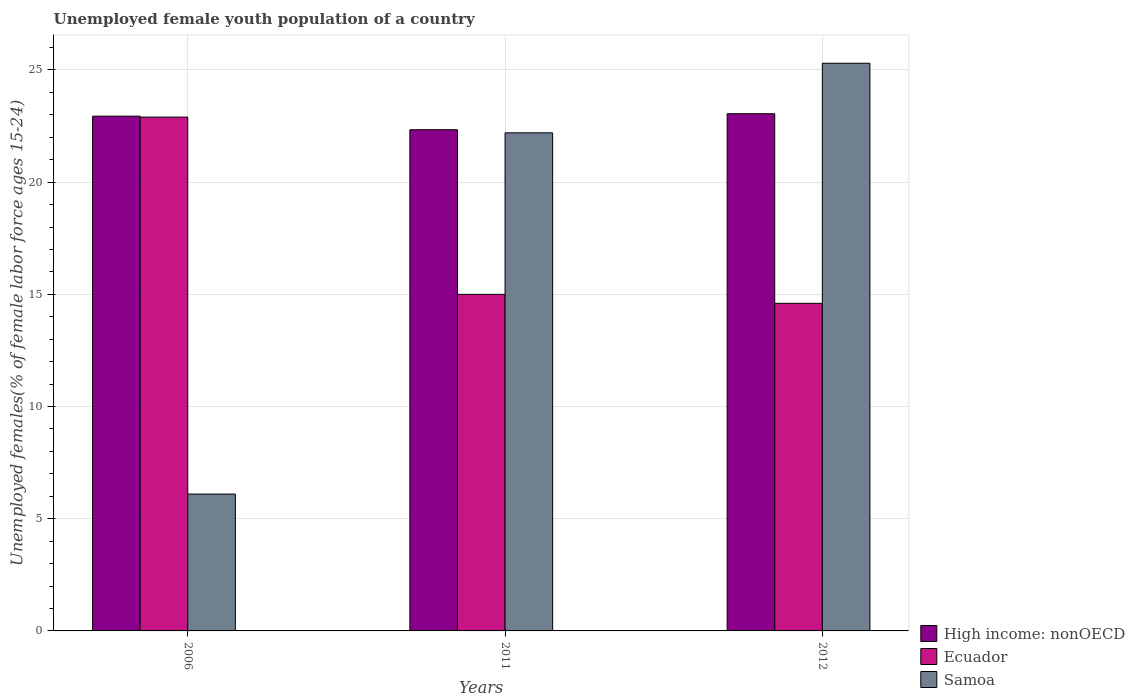How many different coloured bars are there?
Provide a succinct answer. 3. How many bars are there on the 3rd tick from the left?
Make the answer very short. 3. How many bars are there on the 1st tick from the right?
Keep it short and to the point. 3. What is the label of the 1st group of bars from the left?
Your answer should be compact. 2006. What is the percentage of unemployed female youth population in High income: nonOECD in 2006?
Give a very brief answer. 22.94. Across all years, what is the maximum percentage of unemployed female youth population in High income: nonOECD?
Your answer should be very brief. 23.05. Across all years, what is the minimum percentage of unemployed female youth population in High income: nonOECD?
Offer a very short reply. 22.34. In which year was the percentage of unemployed female youth population in High income: nonOECD maximum?
Your answer should be compact. 2012. In which year was the percentage of unemployed female youth population in High income: nonOECD minimum?
Keep it short and to the point. 2011. What is the total percentage of unemployed female youth population in Ecuador in the graph?
Your response must be concise. 52.5. What is the difference between the percentage of unemployed female youth population in High income: nonOECD in 2011 and that in 2012?
Your response must be concise. -0.71. What is the difference between the percentage of unemployed female youth population in Samoa in 2012 and the percentage of unemployed female youth population in Ecuador in 2006?
Give a very brief answer. 2.4. What is the average percentage of unemployed female youth population in Ecuador per year?
Your answer should be compact. 17.5. In the year 2011, what is the difference between the percentage of unemployed female youth population in Samoa and percentage of unemployed female youth population in Ecuador?
Ensure brevity in your answer.  7.2. What is the ratio of the percentage of unemployed female youth population in High income: nonOECD in 2006 to that in 2012?
Give a very brief answer. 1. What is the difference between the highest and the second highest percentage of unemployed female youth population in High income: nonOECD?
Your answer should be compact. 0.11. What is the difference between the highest and the lowest percentage of unemployed female youth population in High income: nonOECD?
Offer a very short reply. 0.71. In how many years, is the percentage of unemployed female youth population in Ecuador greater than the average percentage of unemployed female youth population in Ecuador taken over all years?
Keep it short and to the point. 1. Is the sum of the percentage of unemployed female youth population in High income: nonOECD in 2006 and 2012 greater than the maximum percentage of unemployed female youth population in Samoa across all years?
Provide a short and direct response. Yes. What does the 2nd bar from the left in 2006 represents?
Offer a terse response. Ecuador. What does the 3rd bar from the right in 2006 represents?
Keep it short and to the point. High income: nonOECD. Is it the case that in every year, the sum of the percentage of unemployed female youth population in Ecuador and percentage of unemployed female youth population in High income: nonOECD is greater than the percentage of unemployed female youth population in Samoa?
Your answer should be compact. Yes. Are all the bars in the graph horizontal?
Your answer should be very brief. No. How many years are there in the graph?
Your answer should be compact. 3. Are the values on the major ticks of Y-axis written in scientific E-notation?
Provide a succinct answer. No. Does the graph contain grids?
Your response must be concise. Yes. How many legend labels are there?
Offer a very short reply. 3. How are the legend labels stacked?
Keep it short and to the point. Vertical. What is the title of the graph?
Offer a very short reply. Unemployed female youth population of a country. What is the label or title of the X-axis?
Your answer should be compact. Years. What is the label or title of the Y-axis?
Give a very brief answer. Unemployed females(% of female labor force ages 15-24). What is the Unemployed females(% of female labor force ages 15-24) in High income: nonOECD in 2006?
Provide a succinct answer. 22.94. What is the Unemployed females(% of female labor force ages 15-24) of Ecuador in 2006?
Ensure brevity in your answer.  22.9. What is the Unemployed females(% of female labor force ages 15-24) of Samoa in 2006?
Your answer should be compact. 6.1. What is the Unemployed females(% of female labor force ages 15-24) of High income: nonOECD in 2011?
Provide a short and direct response. 22.34. What is the Unemployed females(% of female labor force ages 15-24) in Samoa in 2011?
Offer a terse response. 22.2. What is the Unemployed females(% of female labor force ages 15-24) of High income: nonOECD in 2012?
Offer a terse response. 23.05. What is the Unemployed females(% of female labor force ages 15-24) of Ecuador in 2012?
Provide a short and direct response. 14.6. What is the Unemployed females(% of female labor force ages 15-24) of Samoa in 2012?
Ensure brevity in your answer.  25.3. Across all years, what is the maximum Unemployed females(% of female labor force ages 15-24) in High income: nonOECD?
Ensure brevity in your answer.  23.05. Across all years, what is the maximum Unemployed females(% of female labor force ages 15-24) in Ecuador?
Your response must be concise. 22.9. Across all years, what is the maximum Unemployed females(% of female labor force ages 15-24) in Samoa?
Provide a succinct answer. 25.3. Across all years, what is the minimum Unemployed females(% of female labor force ages 15-24) of High income: nonOECD?
Offer a terse response. 22.34. Across all years, what is the minimum Unemployed females(% of female labor force ages 15-24) of Ecuador?
Your response must be concise. 14.6. Across all years, what is the minimum Unemployed females(% of female labor force ages 15-24) of Samoa?
Give a very brief answer. 6.1. What is the total Unemployed females(% of female labor force ages 15-24) in High income: nonOECD in the graph?
Make the answer very short. 68.33. What is the total Unemployed females(% of female labor force ages 15-24) in Ecuador in the graph?
Your answer should be compact. 52.5. What is the total Unemployed females(% of female labor force ages 15-24) of Samoa in the graph?
Keep it short and to the point. 53.6. What is the difference between the Unemployed females(% of female labor force ages 15-24) of High income: nonOECD in 2006 and that in 2011?
Make the answer very short. 0.61. What is the difference between the Unemployed females(% of female labor force ages 15-24) in Samoa in 2006 and that in 2011?
Your answer should be very brief. -16.1. What is the difference between the Unemployed females(% of female labor force ages 15-24) of High income: nonOECD in 2006 and that in 2012?
Make the answer very short. -0.11. What is the difference between the Unemployed females(% of female labor force ages 15-24) of Ecuador in 2006 and that in 2012?
Provide a short and direct response. 8.3. What is the difference between the Unemployed females(% of female labor force ages 15-24) in Samoa in 2006 and that in 2012?
Your answer should be compact. -19.2. What is the difference between the Unemployed females(% of female labor force ages 15-24) in High income: nonOECD in 2011 and that in 2012?
Keep it short and to the point. -0.71. What is the difference between the Unemployed females(% of female labor force ages 15-24) of Samoa in 2011 and that in 2012?
Your answer should be compact. -3.1. What is the difference between the Unemployed females(% of female labor force ages 15-24) of High income: nonOECD in 2006 and the Unemployed females(% of female labor force ages 15-24) of Ecuador in 2011?
Your response must be concise. 7.94. What is the difference between the Unemployed females(% of female labor force ages 15-24) of High income: nonOECD in 2006 and the Unemployed females(% of female labor force ages 15-24) of Samoa in 2011?
Provide a short and direct response. 0.74. What is the difference between the Unemployed females(% of female labor force ages 15-24) in High income: nonOECD in 2006 and the Unemployed females(% of female labor force ages 15-24) in Ecuador in 2012?
Provide a short and direct response. 8.34. What is the difference between the Unemployed females(% of female labor force ages 15-24) in High income: nonOECD in 2006 and the Unemployed females(% of female labor force ages 15-24) in Samoa in 2012?
Your answer should be very brief. -2.36. What is the difference between the Unemployed females(% of female labor force ages 15-24) in High income: nonOECD in 2011 and the Unemployed females(% of female labor force ages 15-24) in Ecuador in 2012?
Give a very brief answer. 7.74. What is the difference between the Unemployed females(% of female labor force ages 15-24) in High income: nonOECD in 2011 and the Unemployed females(% of female labor force ages 15-24) in Samoa in 2012?
Provide a succinct answer. -2.96. What is the difference between the Unemployed females(% of female labor force ages 15-24) in Ecuador in 2011 and the Unemployed females(% of female labor force ages 15-24) in Samoa in 2012?
Make the answer very short. -10.3. What is the average Unemployed females(% of female labor force ages 15-24) in High income: nonOECD per year?
Your answer should be compact. 22.78. What is the average Unemployed females(% of female labor force ages 15-24) in Samoa per year?
Provide a succinct answer. 17.87. In the year 2006, what is the difference between the Unemployed females(% of female labor force ages 15-24) in High income: nonOECD and Unemployed females(% of female labor force ages 15-24) in Ecuador?
Your response must be concise. 0.04. In the year 2006, what is the difference between the Unemployed females(% of female labor force ages 15-24) in High income: nonOECD and Unemployed females(% of female labor force ages 15-24) in Samoa?
Provide a short and direct response. 16.84. In the year 2006, what is the difference between the Unemployed females(% of female labor force ages 15-24) in Ecuador and Unemployed females(% of female labor force ages 15-24) in Samoa?
Provide a succinct answer. 16.8. In the year 2011, what is the difference between the Unemployed females(% of female labor force ages 15-24) in High income: nonOECD and Unemployed females(% of female labor force ages 15-24) in Ecuador?
Ensure brevity in your answer.  7.34. In the year 2011, what is the difference between the Unemployed females(% of female labor force ages 15-24) in High income: nonOECD and Unemployed females(% of female labor force ages 15-24) in Samoa?
Your response must be concise. 0.14. In the year 2012, what is the difference between the Unemployed females(% of female labor force ages 15-24) in High income: nonOECD and Unemployed females(% of female labor force ages 15-24) in Ecuador?
Offer a terse response. 8.45. In the year 2012, what is the difference between the Unemployed females(% of female labor force ages 15-24) in High income: nonOECD and Unemployed females(% of female labor force ages 15-24) in Samoa?
Provide a succinct answer. -2.25. What is the ratio of the Unemployed females(% of female labor force ages 15-24) in High income: nonOECD in 2006 to that in 2011?
Your response must be concise. 1.03. What is the ratio of the Unemployed females(% of female labor force ages 15-24) of Ecuador in 2006 to that in 2011?
Provide a short and direct response. 1.53. What is the ratio of the Unemployed females(% of female labor force ages 15-24) of Samoa in 2006 to that in 2011?
Ensure brevity in your answer.  0.27. What is the ratio of the Unemployed females(% of female labor force ages 15-24) in Ecuador in 2006 to that in 2012?
Give a very brief answer. 1.57. What is the ratio of the Unemployed females(% of female labor force ages 15-24) of Samoa in 2006 to that in 2012?
Make the answer very short. 0.24. What is the ratio of the Unemployed females(% of female labor force ages 15-24) in High income: nonOECD in 2011 to that in 2012?
Ensure brevity in your answer.  0.97. What is the ratio of the Unemployed females(% of female labor force ages 15-24) of Ecuador in 2011 to that in 2012?
Offer a terse response. 1.03. What is the ratio of the Unemployed females(% of female labor force ages 15-24) in Samoa in 2011 to that in 2012?
Your response must be concise. 0.88. What is the difference between the highest and the second highest Unemployed females(% of female labor force ages 15-24) of High income: nonOECD?
Provide a succinct answer. 0.11. What is the difference between the highest and the second highest Unemployed females(% of female labor force ages 15-24) in Ecuador?
Your response must be concise. 7.9. What is the difference between the highest and the second highest Unemployed females(% of female labor force ages 15-24) in Samoa?
Keep it short and to the point. 3.1. What is the difference between the highest and the lowest Unemployed females(% of female labor force ages 15-24) in High income: nonOECD?
Ensure brevity in your answer.  0.71. What is the difference between the highest and the lowest Unemployed females(% of female labor force ages 15-24) in Samoa?
Your answer should be compact. 19.2. 